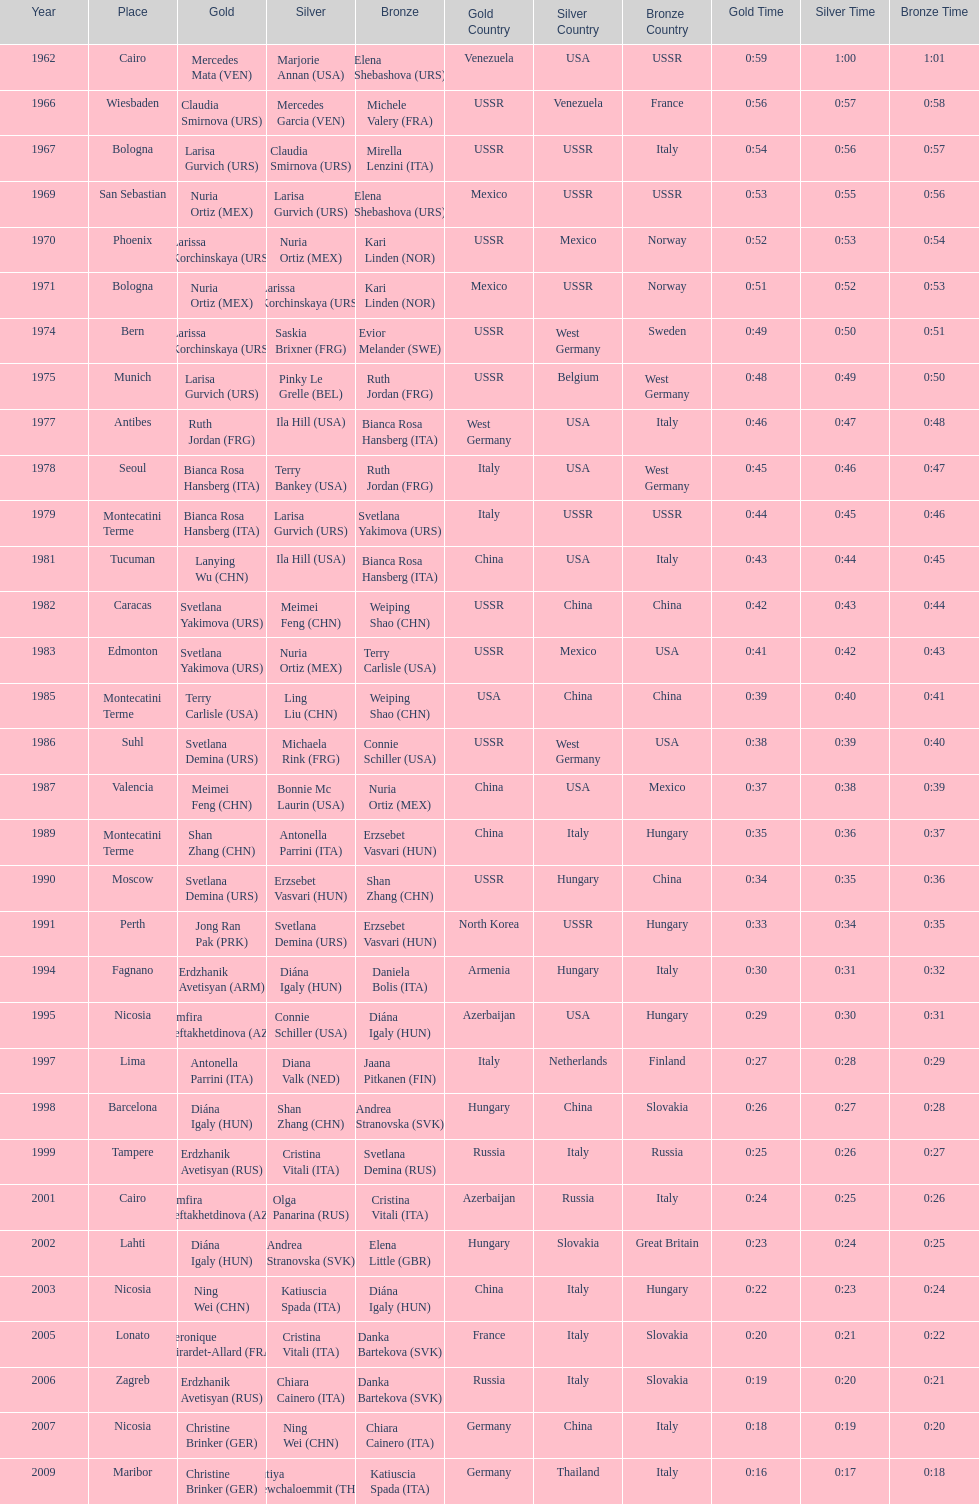Could you parse the entire table as a dict? {'header': ['Year', 'Place', 'Gold', 'Silver', 'Bronze', 'Gold Country', 'Silver Country', 'Bronze Country', 'Gold Time', 'Silver Time', 'Bronze Time'], 'rows': [['1962', 'Cairo', 'Mercedes Mata\xa0(VEN)', 'Marjorie Annan\xa0(USA)', 'Elena Shebashova\xa0(URS)', 'Venezuela', 'USA', 'USSR', '0:59', '1:00', '1:01'], ['1966', 'Wiesbaden', 'Claudia Smirnova\xa0(URS)', 'Mercedes Garcia\xa0(VEN)', 'Michele Valery\xa0(FRA)', 'USSR', 'Venezuela', 'France', '0:56', '0:57', '0:58'], ['1967', 'Bologna', 'Larisa Gurvich\xa0(URS)', 'Claudia Smirnova\xa0(URS)', 'Mirella Lenzini\xa0(ITA)', 'USSR', 'USSR', 'Italy', '0:54', '0:56', '0:57'], ['1969', 'San Sebastian', 'Nuria Ortiz\xa0(MEX)', 'Larisa Gurvich\xa0(URS)', 'Elena Shebashova\xa0(URS)', 'Mexico', 'USSR', 'USSR', '0:53', '0:55', '0:56'], ['1970', 'Phoenix', 'Larissa Korchinskaya\xa0(URS)', 'Nuria Ortiz\xa0(MEX)', 'Kari Linden\xa0(NOR)', 'USSR', 'Mexico', 'Norway', '0:52', '0:53', '0:54'], ['1971', 'Bologna', 'Nuria Ortiz\xa0(MEX)', 'Larissa Korchinskaya\xa0(URS)', 'Kari Linden\xa0(NOR)', 'Mexico', 'USSR', 'Norway', '0:51', '0:52', '0:53'], ['1974', 'Bern', 'Larissa Korchinskaya\xa0(URS)', 'Saskia Brixner\xa0(FRG)', 'Evior Melander\xa0(SWE)', 'USSR', 'West Germany', 'Sweden', '0:49', '0:50', '0:51'], ['1975', 'Munich', 'Larisa Gurvich\xa0(URS)', 'Pinky Le Grelle\xa0(BEL)', 'Ruth Jordan\xa0(FRG)', 'USSR', 'Belgium', 'West Germany', '0:48', '0:49', '0:50'], ['1977', 'Antibes', 'Ruth Jordan\xa0(FRG)', 'Ila Hill\xa0(USA)', 'Bianca Rosa Hansberg\xa0(ITA)', 'West Germany', 'USA', 'Italy', '0:46', '0:47', '0:48'], ['1978', 'Seoul', 'Bianca Rosa Hansberg\xa0(ITA)', 'Terry Bankey\xa0(USA)', 'Ruth Jordan\xa0(FRG)', 'Italy', 'USA', 'West Germany', '0:45', '0:46', '0:47'], ['1979', 'Montecatini Terme', 'Bianca Rosa Hansberg\xa0(ITA)', 'Larisa Gurvich\xa0(URS)', 'Svetlana Yakimova\xa0(URS)', 'Italy', 'USSR', 'USSR', '0:44', '0:45', '0:46'], ['1981', 'Tucuman', 'Lanying Wu\xa0(CHN)', 'Ila Hill\xa0(USA)', 'Bianca Rosa Hansberg\xa0(ITA)', 'China', 'USA', 'Italy', '0:43', '0:44', '0:45'], ['1982', 'Caracas', 'Svetlana Yakimova\xa0(URS)', 'Meimei Feng\xa0(CHN)', 'Weiping Shao\xa0(CHN)', 'USSR', 'China', 'China', '0:42', '0:43', '0:44'], ['1983', 'Edmonton', 'Svetlana Yakimova\xa0(URS)', 'Nuria Ortiz\xa0(MEX)', 'Terry Carlisle\xa0(USA)', 'USSR', 'Mexico', 'USA', '0:41', '0:42', '0:43'], ['1985', 'Montecatini Terme', 'Terry Carlisle\xa0(USA)', 'Ling Liu\xa0(CHN)', 'Weiping Shao\xa0(CHN)', 'USA', 'China', 'China', '0:39', '0:40', '0:41'], ['1986', 'Suhl', 'Svetlana Demina\xa0(URS)', 'Michaela Rink\xa0(FRG)', 'Connie Schiller\xa0(USA)', 'USSR', 'West Germany', 'USA', '0:38', '0:39', '0:40'], ['1987', 'Valencia', 'Meimei Feng\xa0(CHN)', 'Bonnie Mc Laurin\xa0(USA)', 'Nuria Ortiz\xa0(MEX)', 'China', 'USA', 'Mexico', '0:37', '0:38', '0:39'], ['1989', 'Montecatini Terme', 'Shan Zhang\xa0(CHN)', 'Antonella Parrini\xa0(ITA)', 'Erzsebet Vasvari\xa0(HUN)', 'China', 'Italy', 'Hungary', '0:35', '0:36', '0:37'], ['1990', 'Moscow', 'Svetlana Demina\xa0(URS)', 'Erzsebet Vasvari\xa0(HUN)', 'Shan Zhang\xa0(CHN)', 'USSR', 'Hungary', 'China', '0:34', '0:35', '0:36'], ['1991', 'Perth', 'Jong Ran Pak\xa0(PRK)', 'Svetlana Demina\xa0(URS)', 'Erzsebet Vasvari\xa0(HUN)', 'North Korea', 'USSR', 'Hungary', '0:33', '0:34', '0:35'], ['1994', 'Fagnano', 'Erdzhanik Avetisyan\xa0(ARM)', 'Diána Igaly\xa0(HUN)', 'Daniela Bolis\xa0(ITA)', 'Armenia', 'Hungary', 'Italy', '0:30', '0:31', '0:32'], ['1995', 'Nicosia', 'Zemfira Meftakhetdinova\xa0(AZE)', 'Connie Schiller\xa0(USA)', 'Diána Igaly\xa0(HUN)', 'Azerbaijan', 'USA', 'Hungary', '0:29', '0:30', '0:31'], ['1997', 'Lima', 'Antonella Parrini\xa0(ITA)', 'Diana Valk\xa0(NED)', 'Jaana Pitkanen\xa0(FIN)', 'Italy', 'Netherlands', 'Finland', '0:27', '0:28', '0:29'], ['1998', 'Barcelona', 'Diána Igaly\xa0(HUN)', 'Shan Zhang\xa0(CHN)', 'Andrea Stranovska\xa0(SVK)', 'Hungary', 'China', 'Slovakia', '0:26', '0:27', '0:28'], ['1999', 'Tampere', 'Erdzhanik Avetisyan\xa0(RUS)', 'Cristina Vitali\xa0(ITA)', 'Svetlana Demina\xa0(RUS)', 'Russia', 'Italy', 'Russia', '0:25', '0:26', '0:27'], ['2001', 'Cairo', 'Zemfira Meftakhetdinova\xa0(AZE)', 'Olga Panarina\xa0(RUS)', 'Cristina Vitali\xa0(ITA)', 'Azerbaijan', 'Russia', 'Italy', '0:24', '0:25', '0:26'], ['2002', 'Lahti', 'Diána Igaly\xa0(HUN)', 'Andrea Stranovska\xa0(SVK)', 'Elena Little\xa0(GBR)', 'Hungary', 'Slovakia', 'Great Britain', '0:23', '0:24', '0:25'], ['2003', 'Nicosia', 'Ning Wei\xa0(CHN)', 'Katiuscia Spada\xa0(ITA)', 'Diána Igaly\xa0(HUN)', 'China', 'Italy', 'Hungary', '0:22', '0:23', '0:24'], ['2005', 'Lonato', 'Veronique Girardet-Allard\xa0(FRA)', 'Cristina Vitali\xa0(ITA)', 'Danka Bartekova\xa0(SVK)', 'France', 'Italy', 'Slovakia', '0:20', '0:21', '0:22'], ['2006', 'Zagreb', 'Erdzhanik Avetisyan\xa0(RUS)', 'Chiara Cainero\xa0(ITA)', 'Danka Bartekova\xa0(SVK)', 'Russia', 'Italy', 'Slovakia', '0:19', '0:20', '0:21'], ['2007', 'Nicosia', 'Christine Brinker\xa0(GER)', 'Ning Wei\xa0(CHN)', 'Chiara Cainero\xa0(ITA)', 'Germany', 'China', 'Italy', '0:18', '0:19', '0:20'], ['2009', 'Maribor', 'Christine Brinker\xa0(GER)', 'Sutiya Jiewchaloemmit\xa0(THA)', 'Katiuscia Spada\xa0(ITA)', 'Germany', 'Thailand', 'Italy', '0:16', '0:17', '0:18']]} What is the total amount of winnings for the united states in gold, silver and bronze? 9. 